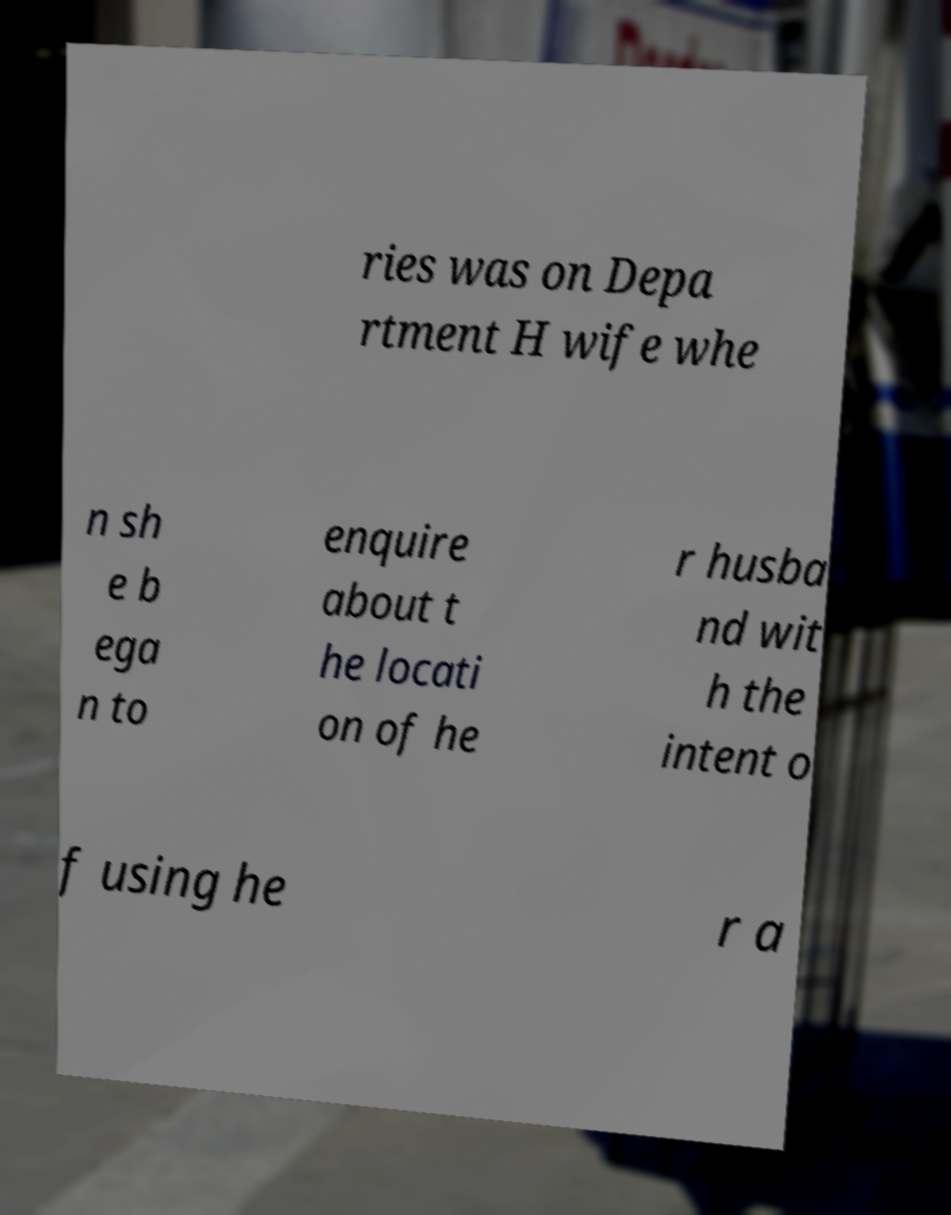There's text embedded in this image that I need extracted. Can you transcribe it verbatim? ries was on Depa rtment H wife whe n sh e b ega n to enquire about t he locati on of he r husba nd wit h the intent o f using he r a 